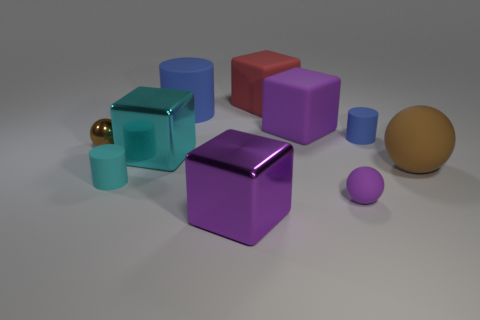How would you describe the ambiance or mood of the image based on its elements? The image conveys a minimalist and tranquil ambiance, characterized by the clean arrangement of shapes and the soft, diffused lighting. The matte surfaces of the objects further contribute to the serene mood, as they soften reflections and imbue the setting with a sense of calmness. 